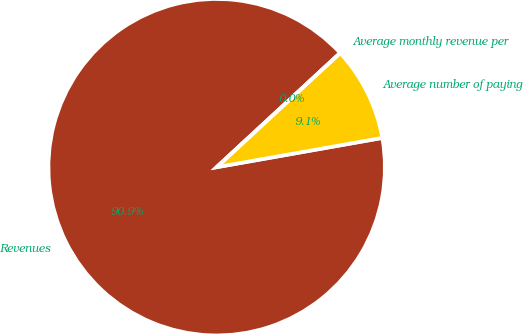<chart> <loc_0><loc_0><loc_500><loc_500><pie_chart><fcel>Revenues<fcel>Average number of paying<fcel>Average monthly revenue per<nl><fcel>90.91%<fcel>9.09%<fcel>0.0%<nl></chart> 